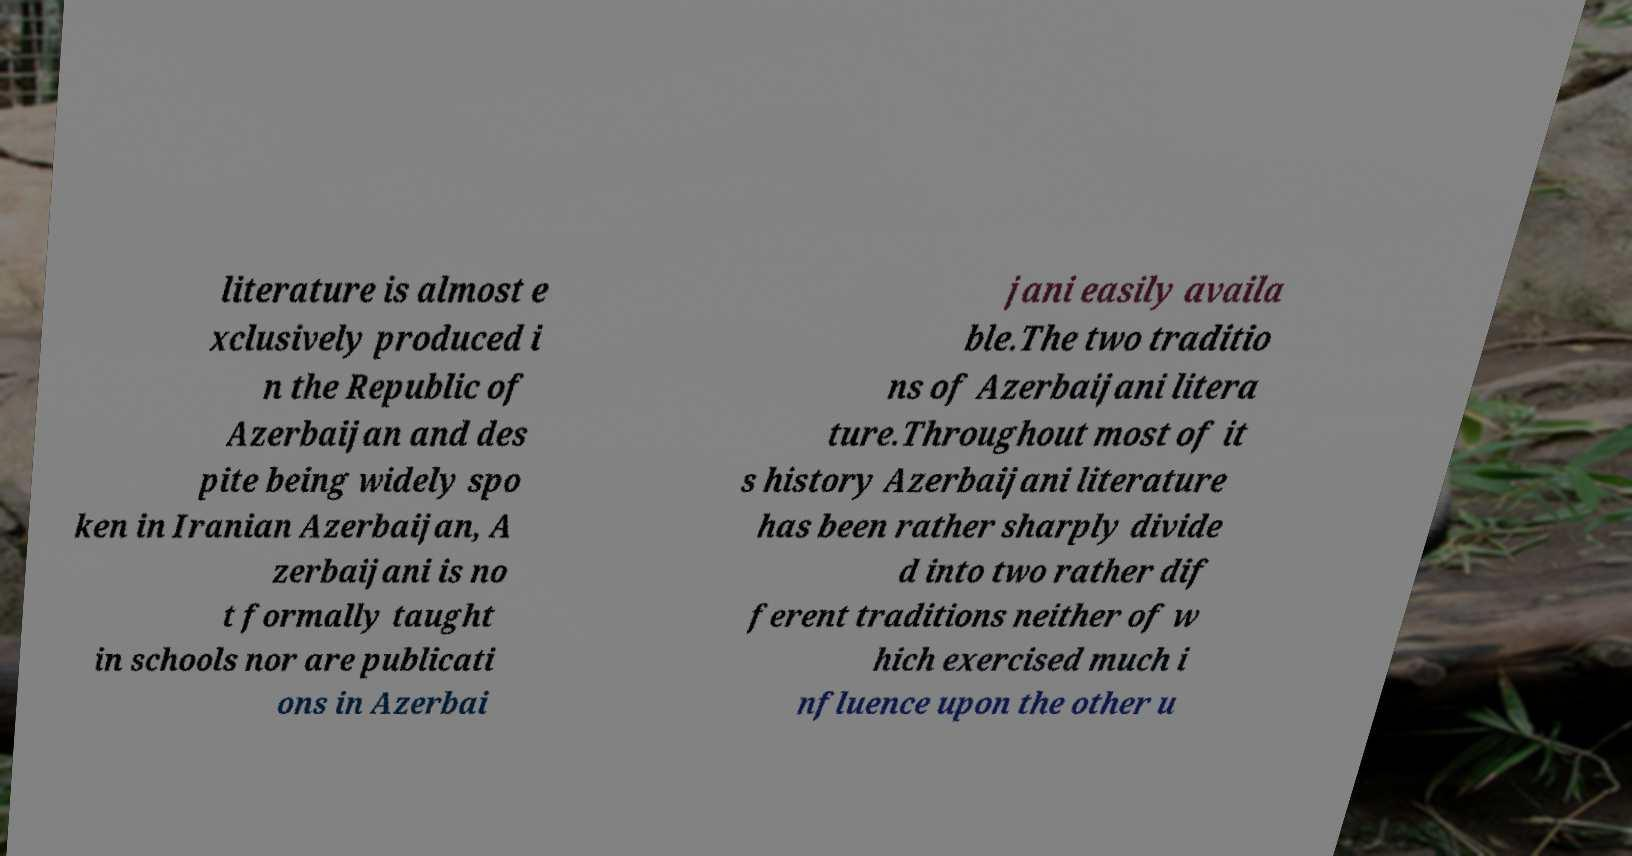For documentation purposes, I need the text within this image transcribed. Could you provide that? literature is almost e xclusively produced i n the Republic of Azerbaijan and des pite being widely spo ken in Iranian Azerbaijan, A zerbaijani is no t formally taught in schools nor are publicati ons in Azerbai jani easily availa ble.The two traditio ns of Azerbaijani litera ture.Throughout most of it s history Azerbaijani literature has been rather sharply divide d into two rather dif ferent traditions neither of w hich exercised much i nfluence upon the other u 